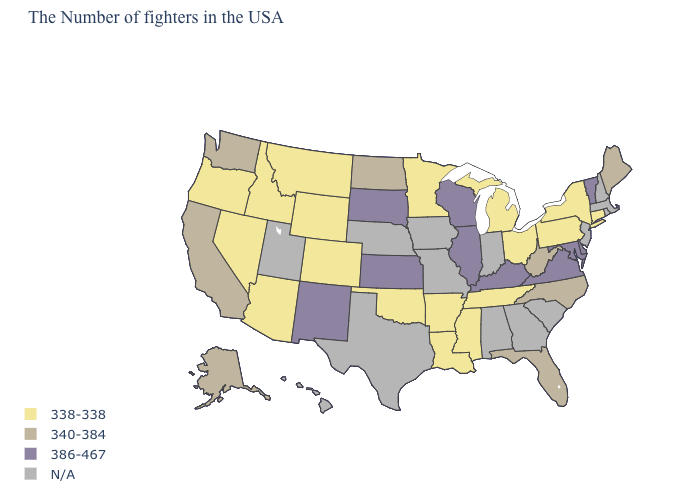Name the states that have a value in the range N/A?
Quick response, please. Massachusetts, Rhode Island, New Hampshire, New Jersey, South Carolina, Georgia, Indiana, Alabama, Missouri, Iowa, Nebraska, Texas, Utah, Hawaii. Name the states that have a value in the range 338-338?
Write a very short answer. Connecticut, New York, Pennsylvania, Ohio, Michigan, Tennessee, Mississippi, Louisiana, Arkansas, Minnesota, Oklahoma, Wyoming, Colorado, Montana, Arizona, Idaho, Nevada, Oregon. What is the value of Wyoming?
Concise answer only. 338-338. Which states have the lowest value in the USA?
Keep it brief. Connecticut, New York, Pennsylvania, Ohio, Michigan, Tennessee, Mississippi, Louisiana, Arkansas, Minnesota, Oklahoma, Wyoming, Colorado, Montana, Arizona, Idaho, Nevada, Oregon. Name the states that have a value in the range 338-338?
Be succinct. Connecticut, New York, Pennsylvania, Ohio, Michigan, Tennessee, Mississippi, Louisiana, Arkansas, Minnesota, Oklahoma, Wyoming, Colorado, Montana, Arizona, Idaho, Nevada, Oregon. Does the first symbol in the legend represent the smallest category?
Keep it brief. Yes. Which states have the lowest value in the South?
Quick response, please. Tennessee, Mississippi, Louisiana, Arkansas, Oklahoma. Name the states that have a value in the range 386-467?
Keep it brief. Vermont, Delaware, Maryland, Virginia, Kentucky, Wisconsin, Illinois, Kansas, South Dakota, New Mexico. Name the states that have a value in the range 340-384?
Concise answer only. Maine, North Carolina, West Virginia, Florida, North Dakota, California, Washington, Alaska. What is the lowest value in the USA?
Answer briefly. 338-338. Does the map have missing data?
Answer briefly. Yes. Does Tennessee have the lowest value in the South?
Give a very brief answer. Yes. What is the value of Idaho?
Concise answer only. 338-338. What is the value of Idaho?
Write a very short answer. 338-338. Among the states that border Pennsylvania , which have the lowest value?
Be succinct. New York, Ohio. 